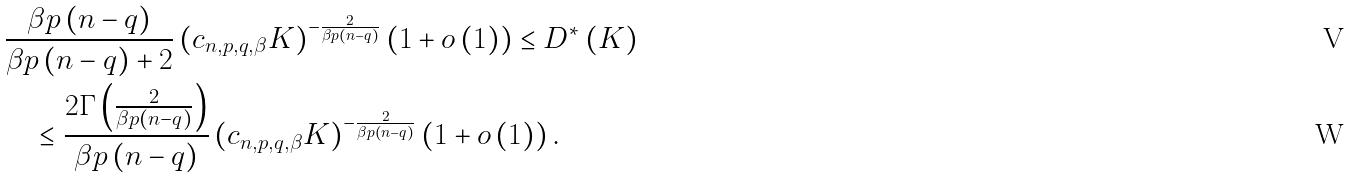Convert formula to latex. <formula><loc_0><loc_0><loc_500><loc_500>& \frac { \beta p \left ( n - q \right ) } { \beta p \left ( n - q \right ) + 2 } \left ( c _ { n , p , q , \beta } K \right ) ^ { - \frac { 2 } { \beta p \left ( n - q \right ) } } \left ( 1 + o \left ( 1 \right ) \right ) \leq D ^ { * } \left ( K \right ) \\ & \quad \leq \frac { 2 \Gamma \left ( \frac { 2 } { \beta p \left ( n - q \right ) } \right ) } { \beta p \left ( n - q \right ) } \left ( c _ { n , p , q , \beta } K \right ) ^ { - \frac { 2 } { \beta p \left ( n - q \right ) } } \left ( 1 + o \left ( 1 \right ) \right ) .</formula> 